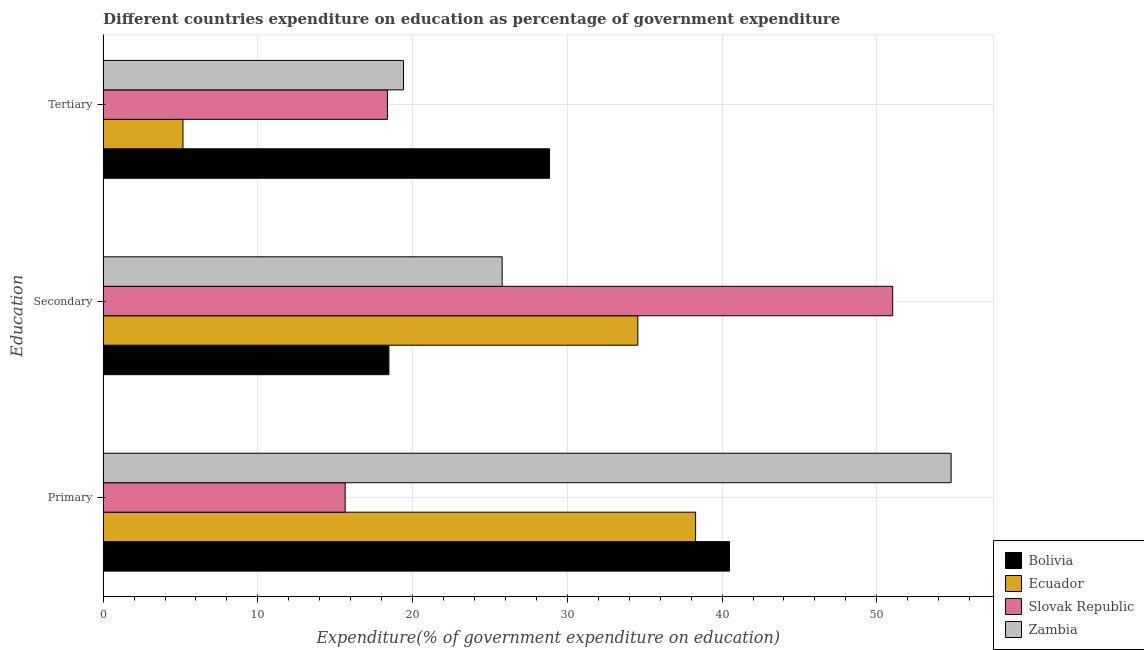How many groups of bars are there?
Offer a terse response. 3. How many bars are there on the 3rd tick from the top?
Your response must be concise. 4. What is the label of the 3rd group of bars from the top?
Keep it short and to the point. Primary. What is the expenditure on tertiary education in Slovak Republic?
Your answer should be very brief. 18.37. Across all countries, what is the maximum expenditure on primary education?
Offer a terse response. 54.8. Across all countries, what is the minimum expenditure on tertiary education?
Your response must be concise. 5.16. In which country was the expenditure on primary education maximum?
Provide a short and direct response. Zambia. What is the total expenditure on secondary education in the graph?
Ensure brevity in your answer.  129.84. What is the difference between the expenditure on tertiary education in Slovak Republic and that in Zambia?
Offer a very short reply. -1.04. What is the difference between the expenditure on secondary education in Ecuador and the expenditure on tertiary education in Slovak Republic?
Offer a very short reply. 16.18. What is the average expenditure on secondary education per country?
Provide a short and direct response. 32.46. What is the difference between the expenditure on tertiary education and expenditure on primary education in Bolivia?
Provide a succinct answer. -11.63. What is the ratio of the expenditure on tertiary education in Bolivia to that in Ecuador?
Offer a terse response. 5.59. Is the expenditure on tertiary education in Bolivia less than that in Zambia?
Give a very brief answer. No. Is the difference between the expenditure on secondary education in Zambia and Slovak Republic greater than the difference between the expenditure on tertiary education in Zambia and Slovak Republic?
Give a very brief answer. No. What is the difference between the highest and the second highest expenditure on tertiary education?
Make the answer very short. 9.44. What is the difference between the highest and the lowest expenditure on tertiary education?
Offer a terse response. 23.69. Is the sum of the expenditure on secondary education in Zambia and Ecuador greater than the maximum expenditure on primary education across all countries?
Your answer should be compact. Yes. What does the 3rd bar from the top in Primary represents?
Provide a short and direct response. Ecuador. What does the 2nd bar from the bottom in Primary represents?
Offer a terse response. Ecuador. Is it the case that in every country, the sum of the expenditure on primary education and expenditure on secondary education is greater than the expenditure on tertiary education?
Your response must be concise. Yes. How many bars are there?
Make the answer very short. 12. How many countries are there in the graph?
Your answer should be compact. 4. What is the difference between two consecutive major ticks on the X-axis?
Your answer should be compact. 10. How many legend labels are there?
Provide a succinct answer. 4. What is the title of the graph?
Provide a succinct answer. Different countries expenditure on education as percentage of government expenditure. Does "Puerto Rico" appear as one of the legend labels in the graph?
Offer a terse response. No. What is the label or title of the X-axis?
Offer a terse response. Expenditure(% of government expenditure on education). What is the label or title of the Y-axis?
Give a very brief answer. Education. What is the Expenditure(% of government expenditure on education) of Bolivia in Primary?
Provide a short and direct response. 40.48. What is the Expenditure(% of government expenditure on education) of Ecuador in Primary?
Your response must be concise. 38.29. What is the Expenditure(% of government expenditure on education) of Slovak Republic in Primary?
Offer a very short reply. 15.64. What is the Expenditure(% of government expenditure on education) of Zambia in Primary?
Your answer should be compact. 54.8. What is the Expenditure(% of government expenditure on education) of Bolivia in Secondary?
Offer a very short reply. 18.47. What is the Expenditure(% of government expenditure on education) of Ecuador in Secondary?
Keep it short and to the point. 34.56. What is the Expenditure(% of government expenditure on education) of Slovak Republic in Secondary?
Give a very brief answer. 51.03. What is the Expenditure(% of government expenditure on education) of Zambia in Secondary?
Give a very brief answer. 25.79. What is the Expenditure(% of government expenditure on education) of Bolivia in Tertiary?
Provide a succinct answer. 28.85. What is the Expenditure(% of government expenditure on education) of Ecuador in Tertiary?
Ensure brevity in your answer.  5.16. What is the Expenditure(% of government expenditure on education) in Slovak Republic in Tertiary?
Give a very brief answer. 18.37. What is the Expenditure(% of government expenditure on education) in Zambia in Tertiary?
Keep it short and to the point. 19.41. Across all Education, what is the maximum Expenditure(% of government expenditure on education) in Bolivia?
Offer a terse response. 40.48. Across all Education, what is the maximum Expenditure(% of government expenditure on education) in Ecuador?
Your response must be concise. 38.29. Across all Education, what is the maximum Expenditure(% of government expenditure on education) in Slovak Republic?
Give a very brief answer. 51.03. Across all Education, what is the maximum Expenditure(% of government expenditure on education) in Zambia?
Provide a succinct answer. 54.8. Across all Education, what is the minimum Expenditure(% of government expenditure on education) of Bolivia?
Your response must be concise. 18.47. Across all Education, what is the minimum Expenditure(% of government expenditure on education) of Ecuador?
Ensure brevity in your answer.  5.16. Across all Education, what is the minimum Expenditure(% of government expenditure on education) of Slovak Republic?
Ensure brevity in your answer.  15.64. Across all Education, what is the minimum Expenditure(% of government expenditure on education) in Zambia?
Offer a very short reply. 19.41. What is the total Expenditure(% of government expenditure on education) in Bolivia in the graph?
Keep it short and to the point. 87.8. What is the total Expenditure(% of government expenditure on education) in Ecuador in the graph?
Provide a succinct answer. 78. What is the total Expenditure(% of government expenditure on education) in Slovak Republic in the graph?
Offer a terse response. 85.04. What is the difference between the Expenditure(% of government expenditure on education) in Bolivia in Primary and that in Secondary?
Offer a very short reply. 22.01. What is the difference between the Expenditure(% of government expenditure on education) in Ecuador in Primary and that in Secondary?
Keep it short and to the point. 3.73. What is the difference between the Expenditure(% of government expenditure on education) in Slovak Republic in Primary and that in Secondary?
Ensure brevity in your answer.  -35.38. What is the difference between the Expenditure(% of government expenditure on education) of Zambia in Primary and that in Secondary?
Give a very brief answer. 29.01. What is the difference between the Expenditure(% of government expenditure on education) in Bolivia in Primary and that in Tertiary?
Make the answer very short. 11.63. What is the difference between the Expenditure(% of government expenditure on education) of Ecuador in Primary and that in Tertiary?
Your answer should be compact. 33.13. What is the difference between the Expenditure(% of government expenditure on education) in Slovak Republic in Primary and that in Tertiary?
Make the answer very short. -2.73. What is the difference between the Expenditure(% of government expenditure on education) in Zambia in Primary and that in Tertiary?
Your answer should be compact. 35.39. What is the difference between the Expenditure(% of government expenditure on education) of Bolivia in Secondary and that in Tertiary?
Make the answer very short. -10.38. What is the difference between the Expenditure(% of government expenditure on education) of Ecuador in Secondary and that in Tertiary?
Your answer should be very brief. 29.4. What is the difference between the Expenditure(% of government expenditure on education) of Slovak Republic in Secondary and that in Tertiary?
Offer a very short reply. 32.65. What is the difference between the Expenditure(% of government expenditure on education) of Zambia in Secondary and that in Tertiary?
Make the answer very short. 6.38. What is the difference between the Expenditure(% of government expenditure on education) of Bolivia in Primary and the Expenditure(% of government expenditure on education) of Ecuador in Secondary?
Offer a very short reply. 5.93. What is the difference between the Expenditure(% of government expenditure on education) in Bolivia in Primary and the Expenditure(% of government expenditure on education) in Slovak Republic in Secondary?
Your answer should be very brief. -10.54. What is the difference between the Expenditure(% of government expenditure on education) in Bolivia in Primary and the Expenditure(% of government expenditure on education) in Zambia in Secondary?
Offer a very short reply. 14.69. What is the difference between the Expenditure(% of government expenditure on education) in Ecuador in Primary and the Expenditure(% of government expenditure on education) in Slovak Republic in Secondary?
Keep it short and to the point. -12.74. What is the difference between the Expenditure(% of government expenditure on education) of Ecuador in Primary and the Expenditure(% of government expenditure on education) of Zambia in Secondary?
Keep it short and to the point. 12.5. What is the difference between the Expenditure(% of government expenditure on education) in Slovak Republic in Primary and the Expenditure(% of government expenditure on education) in Zambia in Secondary?
Offer a very short reply. -10.15. What is the difference between the Expenditure(% of government expenditure on education) in Bolivia in Primary and the Expenditure(% of government expenditure on education) in Ecuador in Tertiary?
Your response must be concise. 35.32. What is the difference between the Expenditure(% of government expenditure on education) of Bolivia in Primary and the Expenditure(% of government expenditure on education) of Slovak Republic in Tertiary?
Ensure brevity in your answer.  22.11. What is the difference between the Expenditure(% of government expenditure on education) in Bolivia in Primary and the Expenditure(% of government expenditure on education) in Zambia in Tertiary?
Offer a terse response. 21.07. What is the difference between the Expenditure(% of government expenditure on education) of Ecuador in Primary and the Expenditure(% of government expenditure on education) of Slovak Republic in Tertiary?
Keep it short and to the point. 19.92. What is the difference between the Expenditure(% of government expenditure on education) in Ecuador in Primary and the Expenditure(% of government expenditure on education) in Zambia in Tertiary?
Offer a terse response. 18.88. What is the difference between the Expenditure(% of government expenditure on education) in Slovak Republic in Primary and the Expenditure(% of government expenditure on education) in Zambia in Tertiary?
Your response must be concise. -3.77. What is the difference between the Expenditure(% of government expenditure on education) of Bolivia in Secondary and the Expenditure(% of government expenditure on education) of Ecuador in Tertiary?
Your response must be concise. 13.31. What is the difference between the Expenditure(% of government expenditure on education) in Bolivia in Secondary and the Expenditure(% of government expenditure on education) in Slovak Republic in Tertiary?
Ensure brevity in your answer.  0.1. What is the difference between the Expenditure(% of government expenditure on education) of Bolivia in Secondary and the Expenditure(% of government expenditure on education) of Zambia in Tertiary?
Your answer should be compact. -0.94. What is the difference between the Expenditure(% of government expenditure on education) in Ecuador in Secondary and the Expenditure(% of government expenditure on education) in Slovak Republic in Tertiary?
Provide a succinct answer. 16.18. What is the difference between the Expenditure(% of government expenditure on education) of Ecuador in Secondary and the Expenditure(% of government expenditure on education) of Zambia in Tertiary?
Provide a short and direct response. 15.15. What is the difference between the Expenditure(% of government expenditure on education) in Slovak Republic in Secondary and the Expenditure(% of government expenditure on education) in Zambia in Tertiary?
Make the answer very short. 31.62. What is the average Expenditure(% of government expenditure on education) in Bolivia per Education?
Provide a short and direct response. 29.27. What is the average Expenditure(% of government expenditure on education) in Ecuador per Education?
Make the answer very short. 26. What is the average Expenditure(% of government expenditure on education) of Slovak Republic per Education?
Provide a short and direct response. 28.35. What is the average Expenditure(% of government expenditure on education) of Zambia per Education?
Provide a succinct answer. 33.33. What is the difference between the Expenditure(% of government expenditure on education) of Bolivia and Expenditure(% of government expenditure on education) of Ecuador in Primary?
Your answer should be very brief. 2.19. What is the difference between the Expenditure(% of government expenditure on education) of Bolivia and Expenditure(% of government expenditure on education) of Slovak Republic in Primary?
Give a very brief answer. 24.84. What is the difference between the Expenditure(% of government expenditure on education) of Bolivia and Expenditure(% of government expenditure on education) of Zambia in Primary?
Your response must be concise. -14.32. What is the difference between the Expenditure(% of government expenditure on education) in Ecuador and Expenditure(% of government expenditure on education) in Slovak Republic in Primary?
Provide a succinct answer. 22.65. What is the difference between the Expenditure(% of government expenditure on education) in Ecuador and Expenditure(% of government expenditure on education) in Zambia in Primary?
Provide a short and direct response. -16.51. What is the difference between the Expenditure(% of government expenditure on education) in Slovak Republic and Expenditure(% of government expenditure on education) in Zambia in Primary?
Your answer should be compact. -39.16. What is the difference between the Expenditure(% of government expenditure on education) in Bolivia and Expenditure(% of government expenditure on education) in Ecuador in Secondary?
Your answer should be compact. -16.09. What is the difference between the Expenditure(% of government expenditure on education) of Bolivia and Expenditure(% of government expenditure on education) of Slovak Republic in Secondary?
Your answer should be compact. -32.56. What is the difference between the Expenditure(% of government expenditure on education) of Bolivia and Expenditure(% of government expenditure on education) of Zambia in Secondary?
Provide a succinct answer. -7.32. What is the difference between the Expenditure(% of government expenditure on education) of Ecuador and Expenditure(% of government expenditure on education) of Slovak Republic in Secondary?
Your answer should be compact. -16.47. What is the difference between the Expenditure(% of government expenditure on education) of Ecuador and Expenditure(% of government expenditure on education) of Zambia in Secondary?
Your answer should be compact. 8.77. What is the difference between the Expenditure(% of government expenditure on education) in Slovak Republic and Expenditure(% of government expenditure on education) in Zambia in Secondary?
Make the answer very short. 25.24. What is the difference between the Expenditure(% of government expenditure on education) of Bolivia and Expenditure(% of government expenditure on education) of Ecuador in Tertiary?
Make the answer very short. 23.69. What is the difference between the Expenditure(% of government expenditure on education) in Bolivia and Expenditure(% of government expenditure on education) in Slovak Republic in Tertiary?
Offer a terse response. 10.48. What is the difference between the Expenditure(% of government expenditure on education) in Bolivia and Expenditure(% of government expenditure on education) in Zambia in Tertiary?
Your response must be concise. 9.44. What is the difference between the Expenditure(% of government expenditure on education) of Ecuador and Expenditure(% of government expenditure on education) of Slovak Republic in Tertiary?
Make the answer very short. -13.21. What is the difference between the Expenditure(% of government expenditure on education) of Ecuador and Expenditure(% of government expenditure on education) of Zambia in Tertiary?
Ensure brevity in your answer.  -14.25. What is the difference between the Expenditure(% of government expenditure on education) in Slovak Republic and Expenditure(% of government expenditure on education) in Zambia in Tertiary?
Provide a succinct answer. -1.04. What is the ratio of the Expenditure(% of government expenditure on education) in Bolivia in Primary to that in Secondary?
Your answer should be compact. 2.19. What is the ratio of the Expenditure(% of government expenditure on education) of Ecuador in Primary to that in Secondary?
Provide a succinct answer. 1.11. What is the ratio of the Expenditure(% of government expenditure on education) in Slovak Republic in Primary to that in Secondary?
Offer a very short reply. 0.31. What is the ratio of the Expenditure(% of government expenditure on education) of Zambia in Primary to that in Secondary?
Your answer should be very brief. 2.13. What is the ratio of the Expenditure(% of government expenditure on education) of Bolivia in Primary to that in Tertiary?
Provide a succinct answer. 1.4. What is the ratio of the Expenditure(% of government expenditure on education) in Ecuador in Primary to that in Tertiary?
Your response must be concise. 7.42. What is the ratio of the Expenditure(% of government expenditure on education) of Slovak Republic in Primary to that in Tertiary?
Keep it short and to the point. 0.85. What is the ratio of the Expenditure(% of government expenditure on education) of Zambia in Primary to that in Tertiary?
Ensure brevity in your answer.  2.82. What is the ratio of the Expenditure(% of government expenditure on education) of Bolivia in Secondary to that in Tertiary?
Provide a short and direct response. 0.64. What is the ratio of the Expenditure(% of government expenditure on education) in Ecuador in Secondary to that in Tertiary?
Your answer should be very brief. 6.7. What is the ratio of the Expenditure(% of government expenditure on education) of Slovak Republic in Secondary to that in Tertiary?
Your answer should be compact. 2.78. What is the ratio of the Expenditure(% of government expenditure on education) of Zambia in Secondary to that in Tertiary?
Your answer should be very brief. 1.33. What is the difference between the highest and the second highest Expenditure(% of government expenditure on education) of Bolivia?
Provide a short and direct response. 11.63. What is the difference between the highest and the second highest Expenditure(% of government expenditure on education) of Ecuador?
Offer a very short reply. 3.73. What is the difference between the highest and the second highest Expenditure(% of government expenditure on education) in Slovak Republic?
Your answer should be very brief. 32.65. What is the difference between the highest and the second highest Expenditure(% of government expenditure on education) in Zambia?
Give a very brief answer. 29.01. What is the difference between the highest and the lowest Expenditure(% of government expenditure on education) in Bolivia?
Keep it short and to the point. 22.01. What is the difference between the highest and the lowest Expenditure(% of government expenditure on education) in Ecuador?
Provide a short and direct response. 33.13. What is the difference between the highest and the lowest Expenditure(% of government expenditure on education) of Slovak Republic?
Keep it short and to the point. 35.38. What is the difference between the highest and the lowest Expenditure(% of government expenditure on education) of Zambia?
Ensure brevity in your answer.  35.39. 